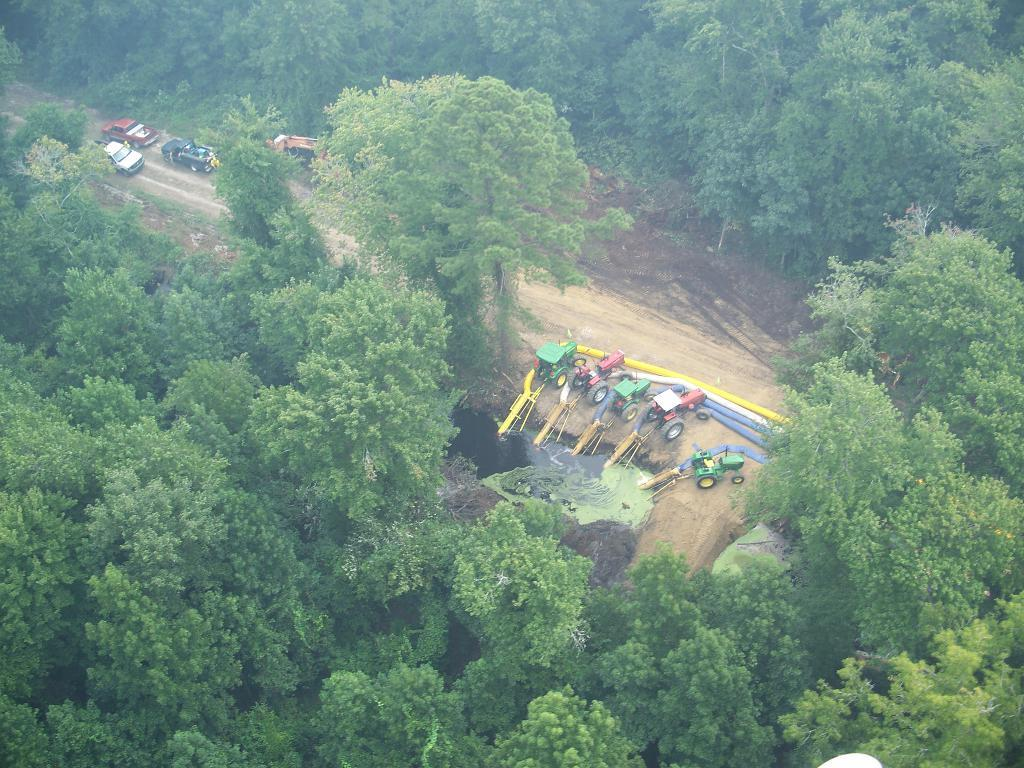What type of vehicles can be seen in the image? There are cars in the image. Where are the vehicles located? The vehicles are on the ground in the image. What else can be seen in the image besides the cars? There are pipes, water, trees, and some unspecified objects in the image. What type of nose can be seen on the cars in the image? Cars do not have noses, so there is no nose present on the cars in the image. 